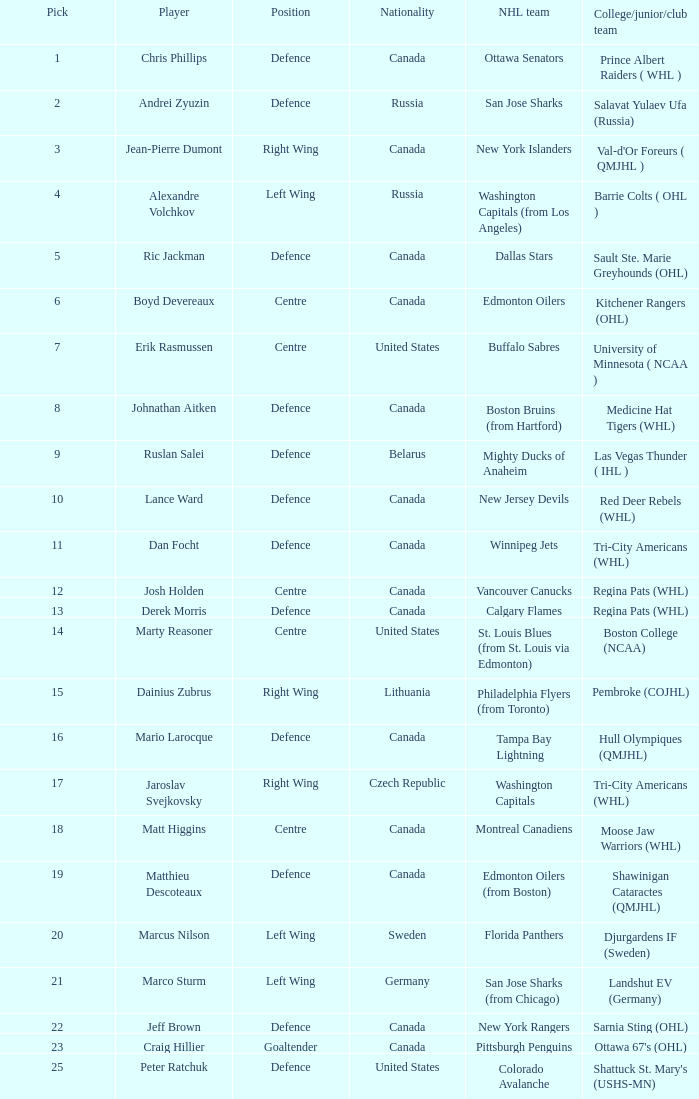What draft pick number was Ric Jackman? 5.0. 